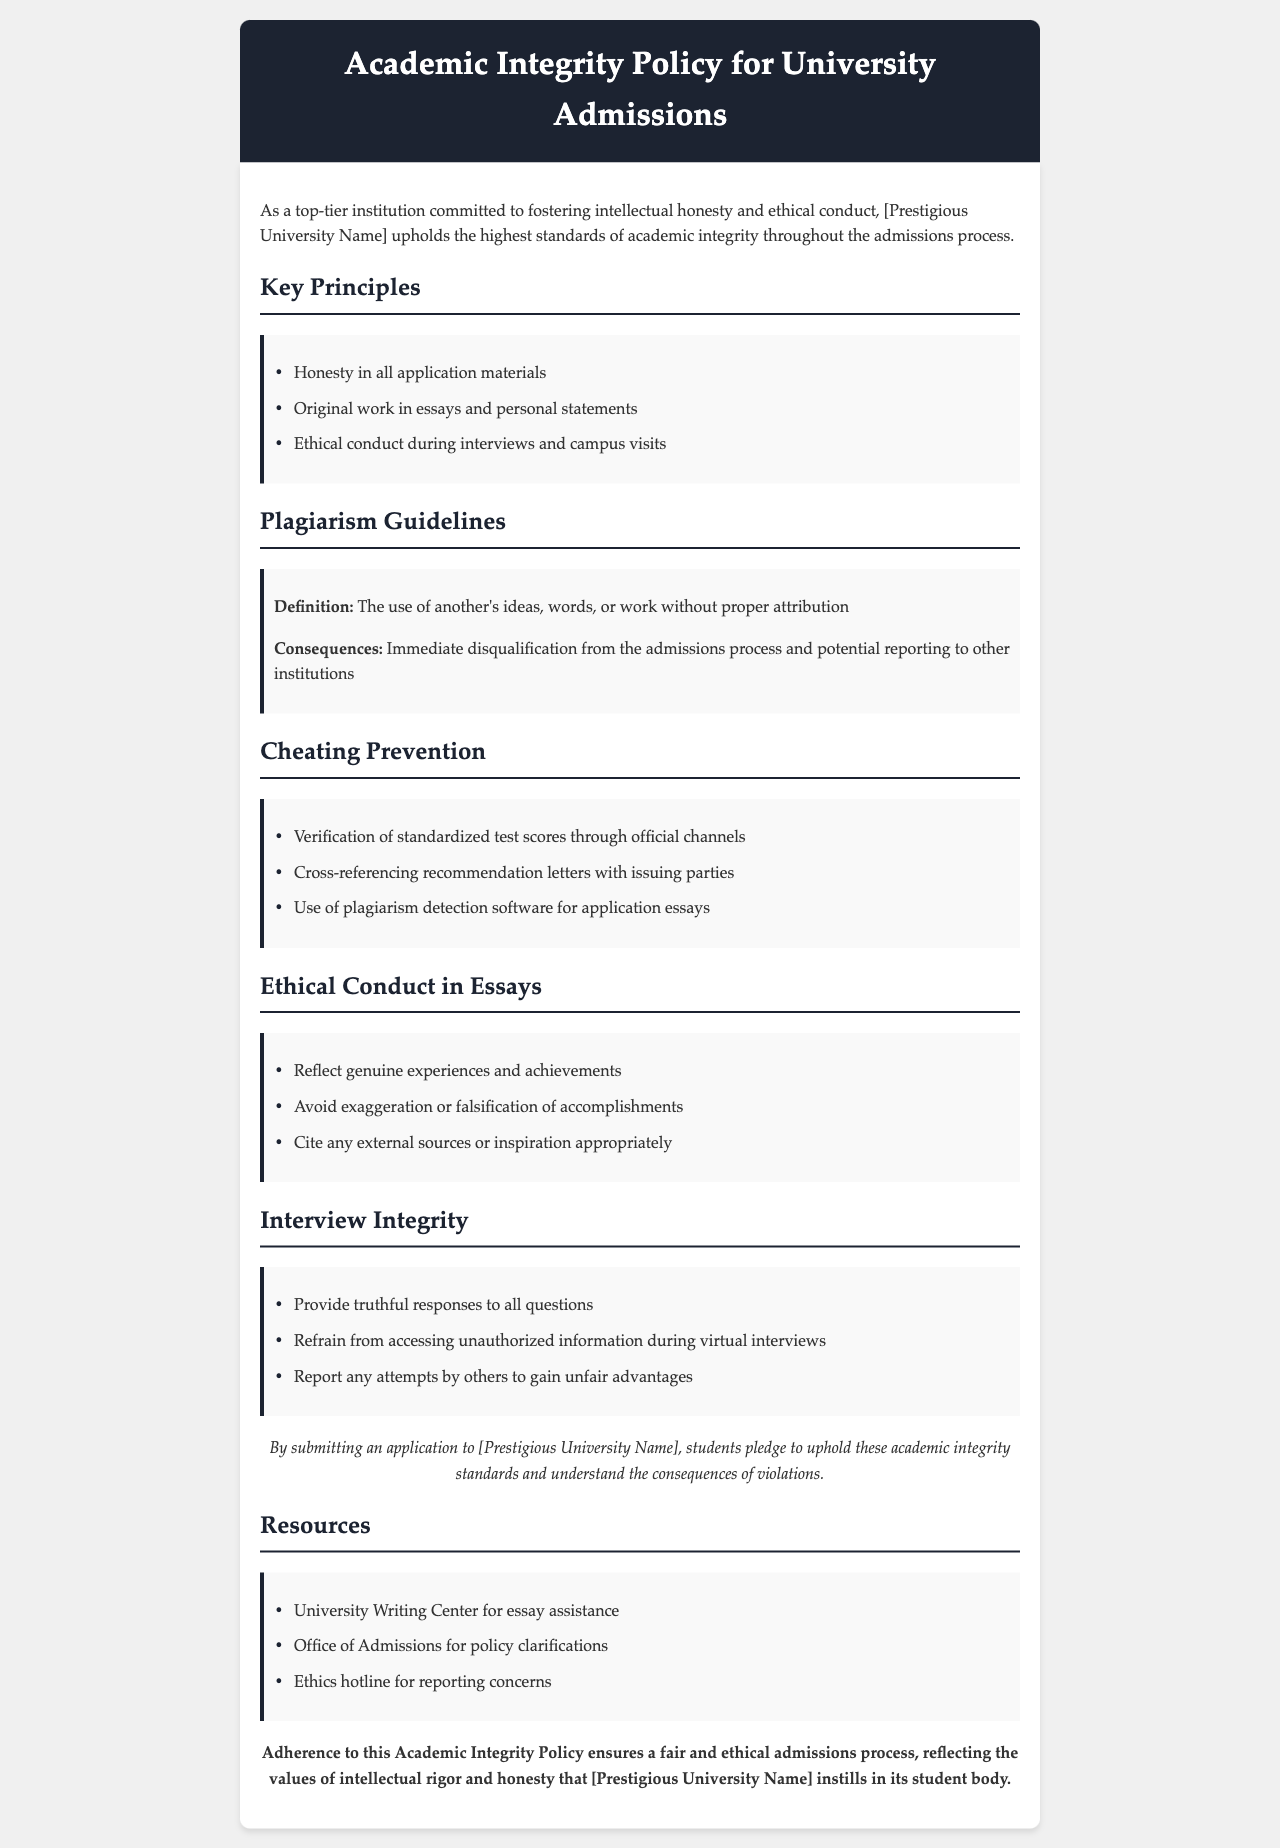What are the key principles of the academic integrity policy? The key principles are listed under a specific section and include honesty, original work, and ethical conduct.
Answer: Honesty in all application materials, Original work in essays and personal statements, Ethical conduct during interviews and campus visits What is the consequence of plagiarism? The document specifies the consequence of plagiarism as a result of not adhering to integrity standards in the admissions process.
Answer: Immediate disqualification from the admissions process and potential reporting to other institutions What should essays reflect according to the ethical conduct guidelines? The ethical conduct section highlights what application essays should authentically represent.
Answer: Genuine experiences and achievements What is prohibited during virtual interviews? The interview integrity section details actions that are not permitted during virtual admissions interviews.
Answer: Accessing unauthorized information How can standardized test scores be verified? The document outlines methods to ensure the authenticity of standardized test scores submitted by applicants.
Answer: Through official channels What institution provides assistance for writing essays? The resources section mentions a specific university service aimed at helping applicants with their essays.
Answer: University Writing Center What type of hotline is mentioned for reporting concerns? The resources section provides information on how applicants can report ethical concerns.
Answer: Ethics hotline How should external sources or inspiration be handled in essays? The ethical conduct guidelines discuss the appropriate way to incorporate outside ideas into application materials.
Answer: Cite any external sources or inspiration appropriately 